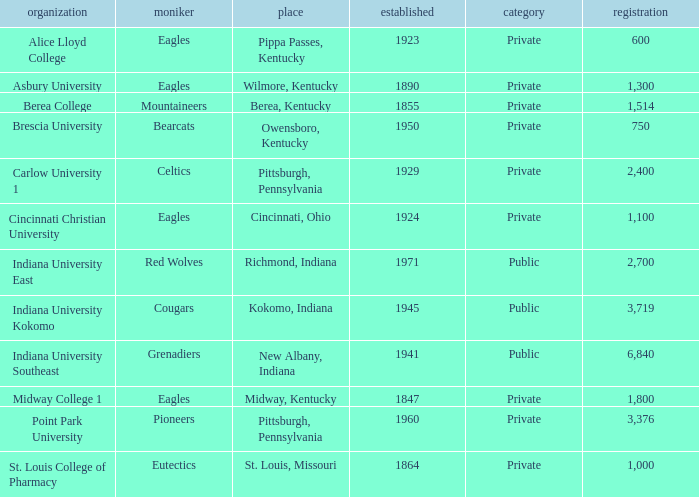Which college's enrollment is less than 1,000? Alice Lloyd College, Brescia University. Can you parse all the data within this table? {'header': ['organization', 'moniker', 'place', 'established', 'category', 'registration'], 'rows': [['Alice Lloyd College', 'Eagles', 'Pippa Passes, Kentucky', '1923', 'Private', '600'], ['Asbury University', 'Eagles', 'Wilmore, Kentucky', '1890', 'Private', '1,300'], ['Berea College', 'Mountaineers', 'Berea, Kentucky', '1855', 'Private', '1,514'], ['Brescia University', 'Bearcats', 'Owensboro, Kentucky', '1950', 'Private', '750'], ['Carlow University 1', 'Celtics', 'Pittsburgh, Pennsylvania', '1929', 'Private', '2,400'], ['Cincinnati Christian University', 'Eagles', 'Cincinnati, Ohio', '1924', 'Private', '1,100'], ['Indiana University East', 'Red Wolves', 'Richmond, Indiana', '1971', 'Public', '2,700'], ['Indiana University Kokomo', 'Cougars', 'Kokomo, Indiana', '1945', 'Public', '3,719'], ['Indiana University Southeast', 'Grenadiers', 'New Albany, Indiana', '1941', 'Public', '6,840'], ['Midway College 1', 'Eagles', 'Midway, Kentucky', '1847', 'Private', '1,800'], ['Point Park University', 'Pioneers', 'Pittsburgh, Pennsylvania', '1960', 'Private', '3,376'], ['St. Louis College of Pharmacy', 'Eutectics', 'St. Louis, Missouri', '1864', 'Private', '1,000']]} 